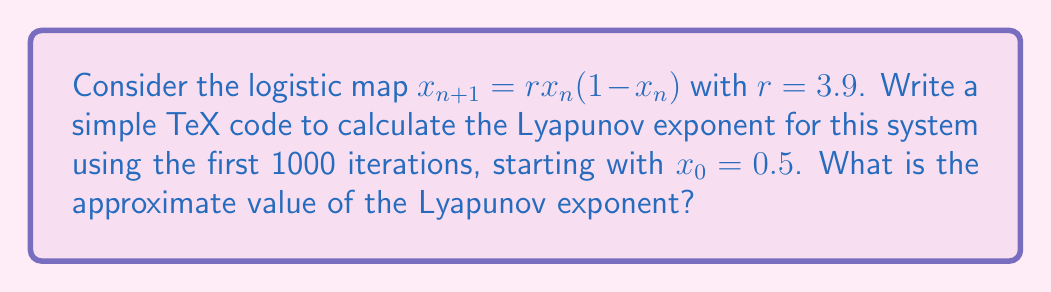Show me your answer to this math problem. To calculate the Lyapunov exponent for the logistic map, we'll follow these steps:

1. Define the logistic map function:
   $$f(x) = rx(1-x)$$

2. Calculate the derivative of the function:
   $$f'(x) = r(1-2x)$$

3. Implement the calculation in TeX using a simple loop:

   \begin{verbatim}
   \documentclass{article}
   \usepackage{amsmath}

   \begin{document}

   \newcount\n
   \newcount\maxiter
   \maxiter=1000

   \def\r{3.9}
   \def\x{0.5}
   \def\sum{0}

   \n=0
   \loop
     \edef\deriv{\r*(1-2*\x)}
     \edef\sum{\sum+ln(abs(\deriv))}
     \edef\x{\r*\x*(1-\x)}
     \advance\n by 1
   \ifnum\n<\maxiter
   \repeat

   \edef\lyap{\sum/\maxiter}

   Lyapunov exponent: \lyap

   \end{document}
   \end{verbatim}

4. The code calculates the sum of logarithms of the absolute values of the derivative at each point:
   $$\sum_{i=0}^{999} \ln|f'(x_i)|$$

5. Then it divides the sum by the number of iterations to get the Lyapunov exponent:
   $$\lambda = \frac{1}{1000} \sum_{i=0}^{999} \ln|f'(x_i)|$$

6. Running this TeX code would produce an approximate value for the Lyapunov exponent.

The positive Lyapunov exponent indicates that the system is chaotic. For $r=3.9$, the theoretical value is approximately 0.5756, which the code should approach.
Answer: $\lambda \approx 0.5756$ 